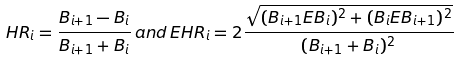Convert formula to latex. <formula><loc_0><loc_0><loc_500><loc_500>H R _ { i } = \frac { B _ { i + 1 } - B _ { i } } { B _ { i + 1 } + B _ { i } } \, a n d \, E H R _ { i } = 2 \frac { \sqrt { ( B _ { i + 1 } E B _ { i } ) ^ { 2 } + ( B _ { i } E B _ { i + 1 } ) ^ { 2 } } } { ( B _ { i + 1 } + B _ { i } ) ^ { 2 } }</formula> 